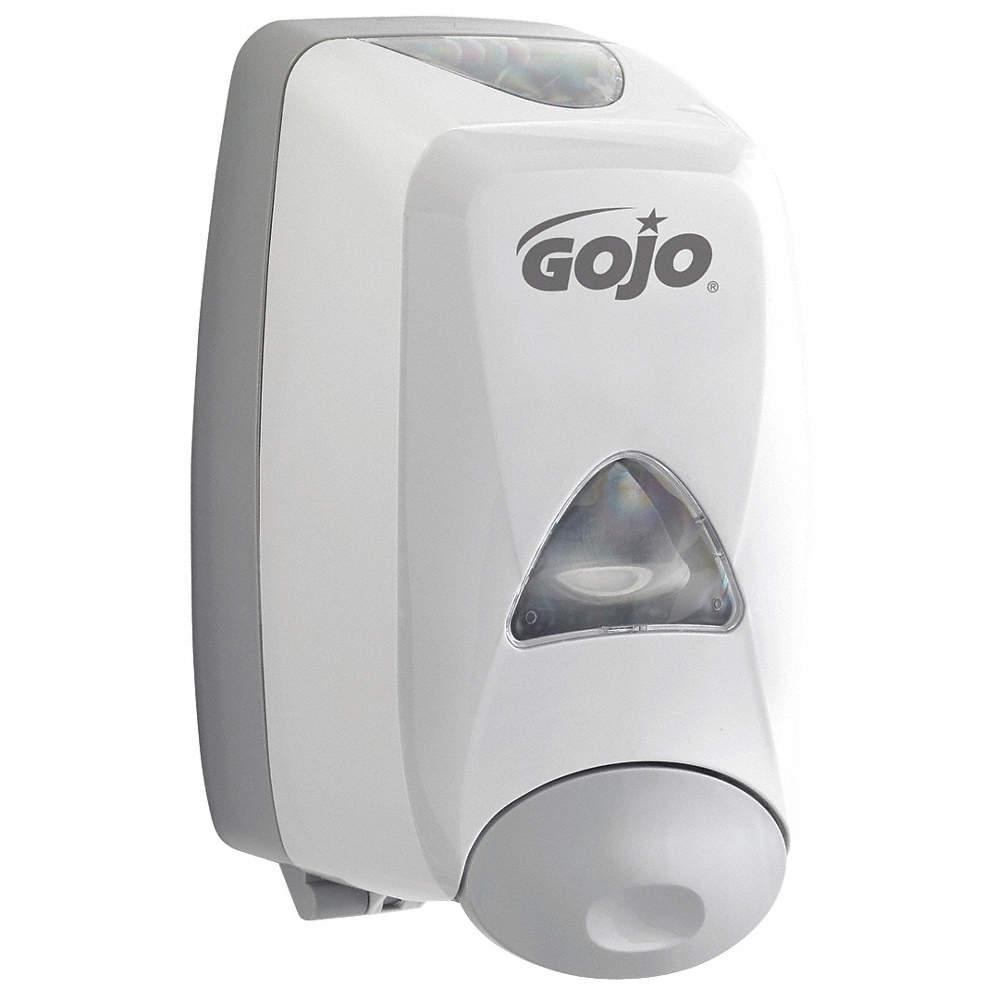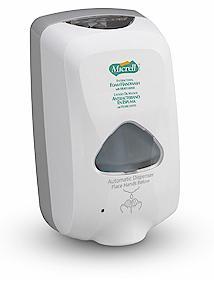The first image is the image on the left, the second image is the image on the right. Considering the images on both sides, is "One of the soap dispensers is significantly darker than the other." valid? Answer yes or no. No. The first image is the image on the left, the second image is the image on the right. Considering the images on both sides, is "There is exactly one white dispenser." valid? Answer yes or no. No. 